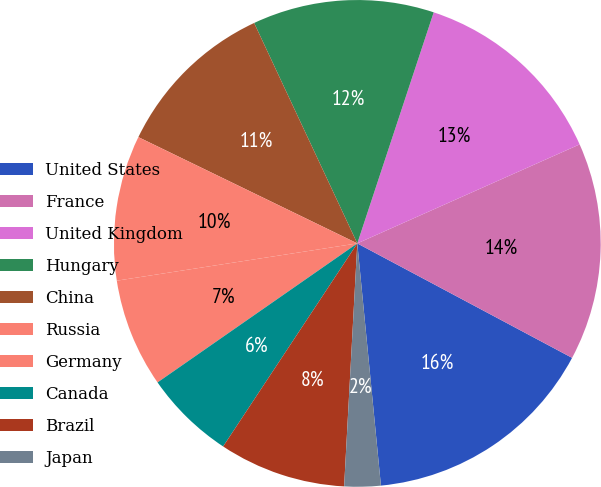Convert chart. <chart><loc_0><loc_0><loc_500><loc_500><pie_chart><fcel>United States<fcel>France<fcel>United Kingdom<fcel>Hungary<fcel>China<fcel>Russia<fcel>Germany<fcel>Canada<fcel>Brazil<fcel>Japan<nl><fcel>15.66%<fcel>14.46%<fcel>13.25%<fcel>12.05%<fcel>10.84%<fcel>9.64%<fcel>7.23%<fcel>6.03%<fcel>8.43%<fcel>2.41%<nl></chart> 